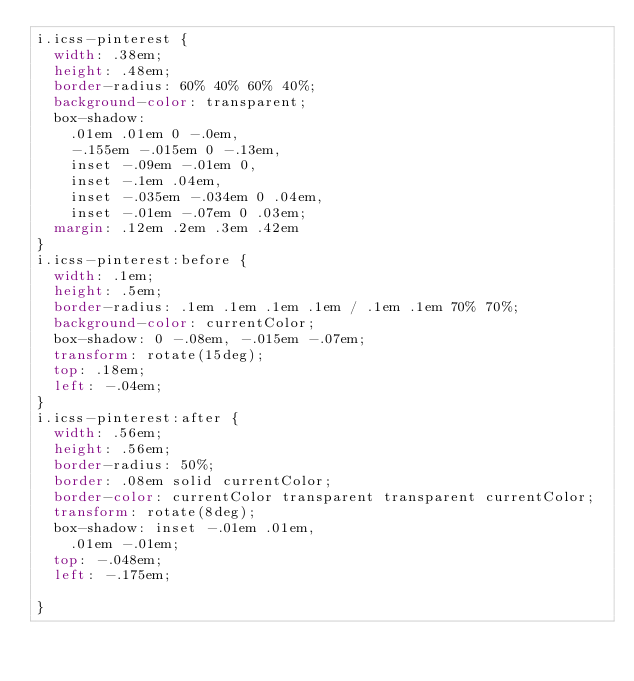<code> <loc_0><loc_0><loc_500><loc_500><_CSS_>i.icss-pinterest {
  width: .38em;
  height: .48em;
  border-radius: 60% 40% 60% 40%; 
  background-color: transparent;
  box-shadow: 
    .01em .01em 0 -.0em,
    -.155em -.015em 0 -.13em,
    inset -.09em -.01em 0,
    inset -.1em .04em,
    inset -.035em -.034em 0 .04em,
    inset -.01em -.07em 0 .03em;
  margin: .12em .2em .3em .42em
}
i.icss-pinterest:before {
  width: .1em;
  height: .5em;
  border-radius: .1em .1em .1em .1em / .1em .1em 70% 70%;
  background-color: currentColor;
  box-shadow: 0 -.08em, -.015em -.07em;
  transform: rotate(15deg);
  top: .18em;
  left: -.04em;
}
i.icss-pinterest:after {
  width: .56em;
  height: .56em;
  border-radius: 50%;
  border: .08em solid currentColor;
  border-color: currentColor transparent transparent currentColor;
  transform: rotate(8deg);
  box-shadow: inset -.01em .01em,
    .01em -.01em;
  top: -.048em;
  left: -.175em;

}</code> 